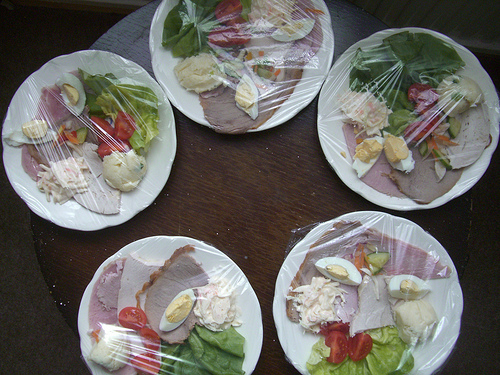<image>
Is there a plate next to the plate? Yes. The plate is positioned adjacent to the plate, located nearby in the same general area. 